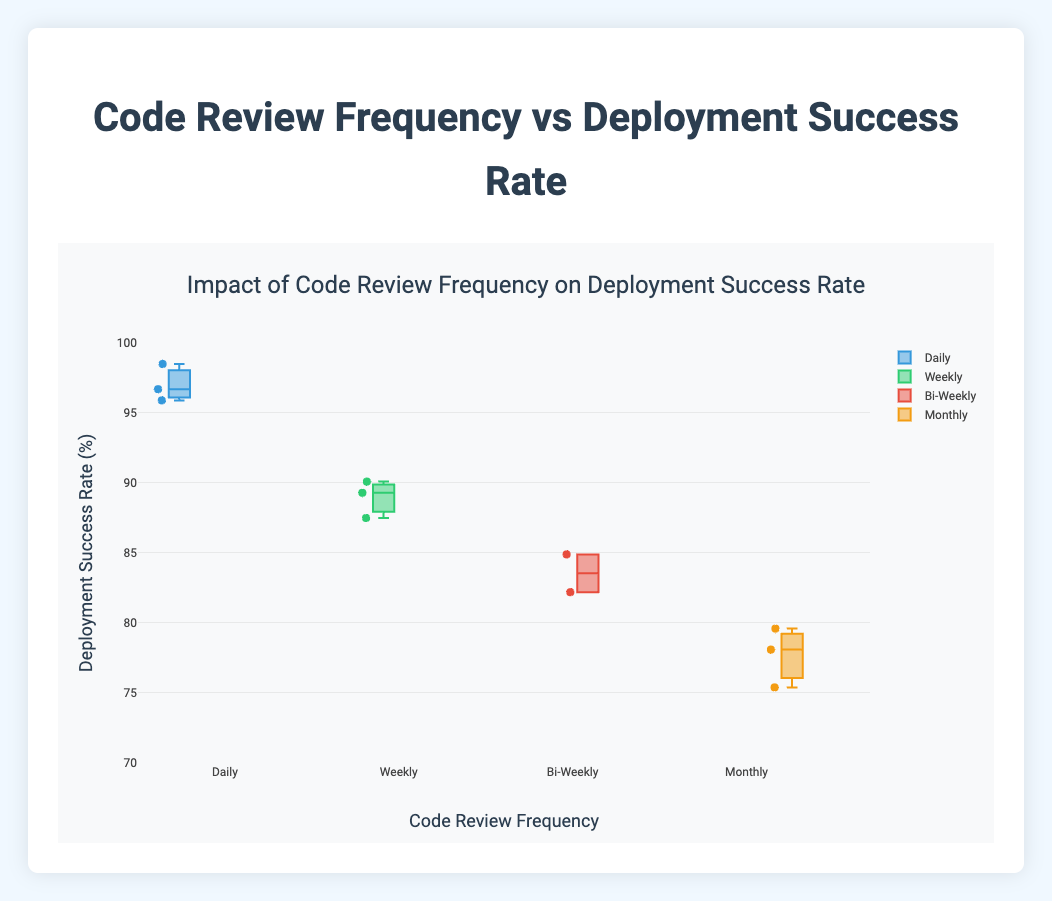What is the title of the figure? The title is displayed at the top center of the figure. It summarizes what the figure is about, helping viewers quickly understand the main topic being visualized.
Answer: Impact of Code Review Frequency on Deployment Success Rate What is the y-axis title? The y-axis title is located along the vertical axis of the figure, indicating the variable being measured on this axis.
Answer: Deployment Success Rate (%) Which code review frequency has the highest median deployment success rate? To find the median values, look for the line inside each box that represents the median. Comparing these lines across different frequencies, identify the highest one.
Answer: Daily How many companies are represented in the figure? Count each of the individual data points represented as individual markers within the box plots across all categories.
Answer: 11 Which code review frequency shows the most variation in deployment success rates? Variation is represented by the height of the box and the spread of the data points (whiskers) in each box plot. Identify which box plot is the tallest and widest.
Answer: Monthly What is the range of deployment success rates for companies with daily code reviews? The range is calculated by identifying the minimum and maximum values (whiskers) for the 'Daily' box plot. Subtract the smallest value from the largest value.
Answer: 95.9 to 98.5 Which specific company has a deployment success rate of 82.2% and what is their code review frequency? Find 82.2% as a data point and trace it back to its corresponding box plot category (code review frequency). Check the company name mentioned next to the point.
Answer: SysDev, Bi-Weekly Between weekly and bi-weekly code review frequencies, which has a higher highest value of deployment success rates? Locate the highest points (top whiskers) for both 'Weekly' and 'Bi-Weekly' categories, then compare which one is higher.
Answer: Weekly What color is used for the box plot representing 'Weekly' code reviews? The color of each box plot can be distinguished by looking at the legend or directly at the box in the figure positioned under the 'Weekly' category.
Answer: Green What's the interquartile range (IQR) for companies with weekly code reviews? The IQR is the difference between the upper quartile (top of the box) and the lower quartile (bottom of the box) for the 'Weekly' category.
Answer: 87.5 to 90.1 